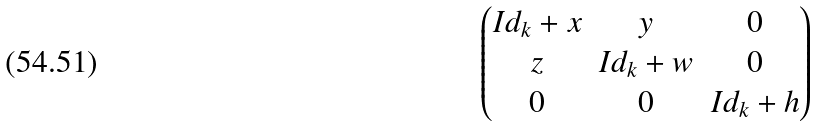<formula> <loc_0><loc_0><loc_500><loc_500>\begin{pmatrix} I d _ { k } + x & y & 0 \\ z & I d _ { k } + w & 0 \\ 0 & 0 & I d _ { k } + h \end{pmatrix}</formula> 